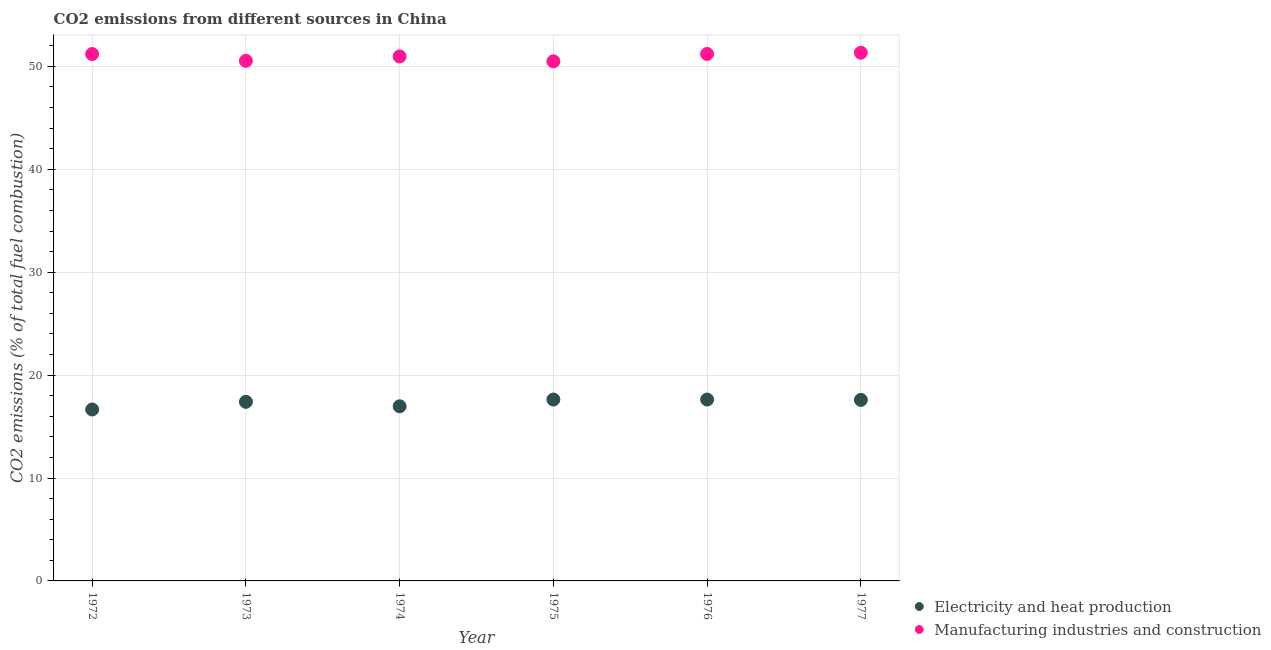Is the number of dotlines equal to the number of legend labels?
Make the answer very short. Yes. What is the co2 emissions due to electricity and heat production in 1973?
Provide a succinct answer. 17.4. Across all years, what is the maximum co2 emissions due to electricity and heat production?
Keep it short and to the point. 17.63. Across all years, what is the minimum co2 emissions due to manufacturing industries?
Offer a terse response. 50.49. In which year was the co2 emissions due to manufacturing industries maximum?
Give a very brief answer. 1977. In which year was the co2 emissions due to electricity and heat production minimum?
Provide a succinct answer. 1972. What is the total co2 emissions due to manufacturing industries in the graph?
Your response must be concise. 305.74. What is the difference between the co2 emissions due to manufacturing industries in 1973 and that in 1977?
Ensure brevity in your answer.  -0.79. What is the difference between the co2 emissions due to electricity and heat production in 1975 and the co2 emissions due to manufacturing industries in 1972?
Provide a short and direct response. -33.57. What is the average co2 emissions due to manufacturing industries per year?
Provide a short and direct response. 50.96. In the year 1976, what is the difference between the co2 emissions due to manufacturing industries and co2 emissions due to electricity and heat production?
Your response must be concise. 33.58. In how many years, is the co2 emissions due to manufacturing industries greater than 4 %?
Keep it short and to the point. 6. What is the ratio of the co2 emissions due to manufacturing industries in 1974 to that in 1976?
Your answer should be very brief. 1. Is the co2 emissions due to electricity and heat production in 1975 less than that in 1976?
Offer a terse response. No. Is the difference between the co2 emissions due to electricity and heat production in 1975 and 1977 greater than the difference between the co2 emissions due to manufacturing industries in 1975 and 1977?
Offer a very short reply. Yes. What is the difference between the highest and the second highest co2 emissions due to electricity and heat production?
Your answer should be very brief. 0. What is the difference between the highest and the lowest co2 emissions due to manufacturing industries?
Provide a succinct answer. 0.84. Does the co2 emissions due to electricity and heat production monotonically increase over the years?
Ensure brevity in your answer.  No. Is the co2 emissions due to electricity and heat production strictly greater than the co2 emissions due to manufacturing industries over the years?
Offer a terse response. No. How many dotlines are there?
Offer a very short reply. 2. How many years are there in the graph?
Keep it short and to the point. 6. What is the difference between two consecutive major ticks on the Y-axis?
Offer a terse response. 10. Are the values on the major ticks of Y-axis written in scientific E-notation?
Ensure brevity in your answer.  No. Does the graph contain any zero values?
Keep it short and to the point. No. Where does the legend appear in the graph?
Your response must be concise. Bottom right. How are the legend labels stacked?
Keep it short and to the point. Vertical. What is the title of the graph?
Give a very brief answer. CO2 emissions from different sources in China. Does "Import" appear as one of the legend labels in the graph?
Give a very brief answer. No. What is the label or title of the Y-axis?
Give a very brief answer. CO2 emissions (% of total fuel combustion). What is the CO2 emissions (% of total fuel combustion) in Electricity and heat production in 1972?
Make the answer very short. 16.66. What is the CO2 emissions (% of total fuel combustion) of Manufacturing industries and construction in 1972?
Keep it short and to the point. 51.2. What is the CO2 emissions (% of total fuel combustion) in Electricity and heat production in 1973?
Offer a terse response. 17.4. What is the CO2 emissions (% of total fuel combustion) of Manufacturing industries and construction in 1973?
Provide a succinct answer. 50.54. What is the CO2 emissions (% of total fuel combustion) of Electricity and heat production in 1974?
Offer a very short reply. 16.97. What is the CO2 emissions (% of total fuel combustion) in Manufacturing industries and construction in 1974?
Provide a succinct answer. 50.97. What is the CO2 emissions (% of total fuel combustion) in Electricity and heat production in 1975?
Your response must be concise. 17.63. What is the CO2 emissions (% of total fuel combustion) of Manufacturing industries and construction in 1975?
Provide a succinct answer. 50.49. What is the CO2 emissions (% of total fuel combustion) of Electricity and heat production in 1976?
Provide a succinct answer. 17.63. What is the CO2 emissions (% of total fuel combustion) of Manufacturing industries and construction in 1976?
Provide a short and direct response. 51.21. What is the CO2 emissions (% of total fuel combustion) in Electricity and heat production in 1977?
Offer a very short reply. 17.59. What is the CO2 emissions (% of total fuel combustion) in Manufacturing industries and construction in 1977?
Your response must be concise. 51.33. Across all years, what is the maximum CO2 emissions (% of total fuel combustion) of Electricity and heat production?
Make the answer very short. 17.63. Across all years, what is the maximum CO2 emissions (% of total fuel combustion) in Manufacturing industries and construction?
Your answer should be very brief. 51.33. Across all years, what is the minimum CO2 emissions (% of total fuel combustion) of Electricity and heat production?
Provide a short and direct response. 16.66. Across all years, what is the minimum CO2 emissions (% of total fuel combustion) in Manufacturing industries and construction?
Your answer should be very brief. 50.49. What is the total CO2 emissions (% of total fuel combustion) in Electricity and heat production in the graph?
Your answer should be compact. 103.87. What is the total CO2 emissions (% of total fuel combustion) of Manufacturing industries and construction in the graph?
Your answer should be compact. 305.74. What is the difference between the CO2 emissions (% of total fuel combustion) in Electricity and heat production in 1972 and that in 1973?
Give a very brief answer. -0.74. What is the difference between the CO2 emissions (% of total fuel combustion) in Manufacturing industries and construction in 1972 and that in 1973?
Offer a terse response. 0.66. What is the difference between the CO2 emissions (% of total fuel combustion) of Electricity and heat production in 1972 and that in 1974?
Ensure brevity in your answer.  -0.31. What is the difference between the CO2 emissions (% of total fuel combustion) in Manufacturing industries and construction in 1972 and that in 1974?
Your response must be concise. 0.24. What is the difference between the CO2 emissions (% of total fuel combustion) in Electricity and heat production in 1972 and that in 1975?
Keep it short and to the point. -0.97. What is the difference between the CO2 emissions (% of total fuel combustion) in Manufacturing industries and construction in 1972 and that in 1975?
Your answer should be very brief. 0.71. What is the difference between the CO2 emissions (% of total fuel combustion) of Electricity and heat production in 1972 and that in 1976?
Make the answer very short. -0.97. What is the difference between the CO2 emissions (% of total fuel combustion) in Manufacturing industries and construction in 1972 and that in 1976?
Offer a very short reply. -0.01. What is the difference between the CO2 emissions (% of total fuel combustion) of Electricity and heat production in 1972 and that in 1977?
Make the answer very short. -0.93. What is the difference between the CO2 emissions (% of total fuel combustion) in Manufacturing industries and construction in 1972 and that in 1977?
Make the answer very short. -0.13. What is the difference between the CO2 emissions (% of total fuel combustion) in Electricity and heat production in 1973 and that in 1974?
Keep it short and to the point. 0.43. What is the difference between the CO2 emissions (% of total fuel combustion) of Manufacturing industries and construction in 1973 and that in 1974?
Provide a succinct answer. -0.42. What is the difference between the CO2 emissions (% of total fuel combustion) in Electricity and heat production in 1973 and that in 1975?
Your response must be concise. -0.22. What is the difference between the CO2 emissions (% of total fuel combustion) in Manufacturing industries and construction in 1973 and that in 1975?
Ensure brevity in your answer.  0.05. What is the difference between the CO2 emissions (% of total fuel combustion) of Electricity and heat production in 1973 and that in 1976?
Give a very brief answer. -0.22. What is the difference between the CO2 emissions (% of total fuel combustion) in Manufacturing industries and construction in 1973 and that in 1976?
Ensure brevity in your answer.  -0.67. What is the difference between the CO2 emissions (% of total fuel combustion) in Electricity and heat production in 1973 and that in 1977?
Offer a very short reply. -0.19. What is the difference between the CO2 emissions (% of total fuel combustion) in Manufacturing industries and construction in 1973 and that in 1977?
Give a very brief answer. -0.79. What is the difference between the CO2 emissions (% of total fuel combustion) in Electricity and heat production in 1974 and that in 1975?
Provide a short and direct response. -0.66. What is the difference between the CO2 emissions (% of total fuel combustion) of Manufacturing industries and construction in 1974 and that in 1975?
Make the answer very short. 0.47. What is the difference between the CO2 emissions (% of total fuel combustion) in Electricity and heat production in 1974 and that in 1976?
Offer a very short reply. -0.66. What is the difference between the CO2 emissions (% of total fuel combustion) of Manufacturing industries and construction in 1974 and that in 1976?
Make the answer very short. -0.24. What is the difference between the CO2 emissions (% of total fuel combustion) of Electricity and heat production in 1974 and that in 1977?
Offer a terse response. -0.62. What is the difference between the CO2 emissions (% of total fuel combustion) in Manufacturing industries and construction in 1974 and that in 1977?
Provide a short and direct response. -0.36. What is the difference between the CO2 emissions (% of total fuel combustion) of Electricity and heat production in 1975 and that in 1976?
Provide a short and direct response. 0. What is the difference between the CO2 emissions (% of total fuel combustion) in Manufacturing industries and construction in 1975 and that in 1976?
Your response must be concise. -0.71. What is the difference between the CO2 emissions (% of total fuel combustion) in Electricity and heat production in 1975 and that in 1977?
Provide a succinct answer. 0.04. What is the difference between the CO2 emissions (% of total fuel combustion) of Manufacturing industries and construction in 1975 and that in 1977?
Give a very brief answer. -0.84. What is the difference between the CO2 emissions (% of total fuel combustion) of Electricity and heat production in 1976 and that in 1977?
Offer a terse response. 0.04. What is the difference between the CO2 emissions (% of total fuel combustion) of Manufacturing industries and construction in 1976 and that in 1977?
Give a very brief answer. -0.12. What is the difference between the CO2 emissions (% of total fuel combustion) of Electricity and heat production in 1972 and the CO2 emissions (% of total fuel combustion) of Manufacturing industries and construction in 1973?
Your response must be concise. -33.88. What is the difference between the CO2 emissions (% of total fuel combustion) in Electricity and heat production in 1972 and the CO2 emissions (% of total fuel combustion) in Manufacturing industries and construction in 1974?
Offer a very short reply. -34.31. What is the difference between the CO2 emissions (% of total fuel combustion) of Electricity and heat production in 1972 and the CO2 emissions (% of total fuel combustion) of Manufacturing industries and construction in 1975?
Make the answer very short. -33.83. What is the difference between the CO2 emissions (% of total fuel combustion) of Electricity and heat production in 1972 and the CO2 emissions (% of total fuel combustion) of Manufacturing industries and construction in 1976?
Your answer should be very brief. -34.55. What is the difference between the CO2 emissions (% of total fuel combustion) in Electricity and heat production in 1972 and the CO2 emissions (% of total fuel combustion) in Manufacturing industries and construction in 1977?
Provide a short and direct response. -34.67. What is the difference between the CO2 emissions (% of total fuel combustion) in Electricity and heat production in 1973 and the CO2 emissions (% of total fuel combustion) in Manufacturing industries and construction in 1974?
Provide a short and direct response. -33.56. What is the difference between the CO2 emissions (% of total fuel combustion) of Electricity and heat production in 1973 and the CO2 emissions (% of total fuel combustion) of Manufacturing industries and construction in 1975?
Offer a very short reply. -33.09. What is the difference between the CO2 emissions (% of total fuel combustion) in Electricity and heat production in 1973 and the CO2 emissions (% of total fuel combustion) in Manufacturing industries and construction in 1976?
Keep it short and to the point. -33.8. What is the difference between the CO2 emissions (% of total fuel combustion) in Electricity and heat production in 1973 and the CO2 emissions (% of total fuel combustion) in Manufacturing industries and construction in 1977?
Provide a short and direct response. -33.93. What is the difference between the CO2 emissions (% of total fuel combustion) of Electricity and heat production in 1974 and the CO2 emissions (% of total fuel combustion) of Manufacturing industries and construction in 1975?
Offer a terse response. -33.52. What is the difference between the CO2 emissions (% of total fuel combustion) in Electricity and heat production in 1974 and the CO2 emissions (% of total fuel combustion) in Manufacturing industries and construction in 1976?
Offer a very short reply. -34.24. What is the difference between the CO2 emissions (% of total fuel combustion) in Electricity and heat production in 1974 and the CO2 emissions (% of total fuel combustion) in Manufacturing industries and construction in 1977?
Your answer should be very brief. -34.36. What is the difference between the CO2 emissions (% of total fuel combustion) in Electricity and heat production in 1975 and the CO2 emissions (% of total fuel combustion) in Manufacturing industries and construction in 1976?
Your response must be concise. -33.58. What is the difference between the CO2 emissions (% of total fuel combustion) of Electricity and heat production in 1975 and the CO2 emissions (% of total fuel combustion) of Manufacturing industries and construction in 1977?
Provide a short and direct response. -33.7. What is the difference between the CO2 emissions (% of total fuel combustion) in Electricity and heat production in 1976 and the CO2 emissions (% of total fuel combustion) in Manufacturing industries and construction in 1977?
Your response must be concise. -33.7. What is the average CO2 emissions (% of total fuel combustion) in Electricity and heat production per year?
Your answer should be very brief. 17.31. What is the average CO2 emissions (% of total fuel combustion) of Manufacturing industries and construction per year?
Give a very brief answer. 50.96. In the year 1972, what is the difference between the CO2 emissions (% of total fuel combustion) in Electricity and heat production and CO2 emissions (% of total fuel combustion) in Manufacturing industries and construction?
Ensure brevity in your answer.  -34.54. In the year 1973, what is the difference between the CO2 emissions (% of total fuel combustion) in Electricity and heat production and CO2 emissions (% of total fuel combustion) in Manufacturing industries and construction?
Make the answer very short. -33.14. In the year 1974, what is the difference between the CO2 emissions (% of total fuel combustion) of Electricity and heat production and CO2 emissions (% of total fuel combustion) of Manufacturing industries and construction?
Your answer should be compact. -34. In the year 1975, what is the difference between the CO2 emissions (% of total fuel combustion) in Electricity and heat production and CO2 emissions (% of total fuel combustion) in Manufacturing industries and construction?
Make the answer very short. -32.87. In the year 1976, what is the difference between the CO2 emissions (% of total fuel combustion) in Electricity and heat production and CO2 emissions (% of total fuel combustion) in Manufacturing industries and construction?
Make the answer very short. -33.58. In the year 1977, what is the difference between the CO2 emissions (% of total fuel combustion) of Electricity and heat production and CO2 emissions (% of total fuel combustion) of Manufacturing industries and construction?
Offer a terse response. -33.74. What is the ratio of the CO2 emissions (% of total fuel combustion) of Electricity and heat production in 1972 to that in 1973?
Make the answer very short. 0.96. What is the ratio of the CO2 emissions (% of total fuel combustion) in Manufacturing industries and construction in 1972 to that in 1973?
Offer a terse response. 1.01. What is the ratio of the CO2 emissions (% of total fuel combustion) in Electricity and heat production in 1972 to that in 1974?
Ensure brevity in your answer.  0.98. What is the ratio of the CO2 emissions (% of total fuel combustion) in Electricity and heat production in 1972 to that in 1975?
Your response must be concise. 0.95. What is the ratio of the CO2 emissions (% of total fuel combustion) of Manufacturing industries and construction in 1972 to that in 1975?
Keep it short and to the point. 1.01. What is the ratio of the CO2 emissions (% of total fuel combustion) of Electricity and heat production in 1972 to that in 1976?
Make the answer very short. 0.95. What is the ratio of the CO2 emissions (% of total fuel combustion) of Manufacturing industries and construction in 1972 to that in 1976?
Keep it short and to the point. 1. What is the ratio of the CO2 emissions (% of total fuel combustion) of Electricity and heat production in 1972 to that in 1977?
Offer a terse response. 0.95. What is the ratio of the CO2 emissions (% of total fuel combustion) in Manufacturing industries and construction in 1972 to that in 1977?
Provide a short and direct response. 1. What is the ratio of the CO2 emissions (% of total fuel combustion) in Electricity and heat production in 1973 to that in 1974?
Offer a very short reply. 1.03. What is the ratio of the CO2 emissions (% of total fuel combustion) of Electricity and heat production in 1973 to that in 1975?
Your response must be concise. 0.99. What is the ratio of the CO2 emissions (% of total fuel combustion) in Manufacturing industries and construction in 1973 to that in 1975?
Offer a terse response. 1. What is the ratio of the CO2 emissions (% of total fuel combustion) in Electricity and heat production in 1973 to that in 1976?
Offer a very short reply. 0.99. What is the ratio of the CO2 emissions (% of total fuel combustion) of Electricity and heat production in 1973 to that in 1977?
Make the answer very short. 0.99. What is the ratio of the CO2 emissions (% of total fuel combustion) of Manufacturing industries and construction in 1973 to that in 1977?
Provide a succinct answer. 0.98. What is the ratio of the CO2 emissions (% of total fuel combustion) of Electricity and heat production in 1974 to that in 1975?
Your response must be concise. 0.96. What is the ratio of the CO2 emissions (% of total fuel combustion) in Manufacturing industries and construction in 1974 to that in 1975?
Make the answer very short. 1.01. What is the ratio of the CO2 emissions (% of total fuel combustion) in Electricity and heat production in 1974 to that in 1976?
Keep it short and to the point. 0.96. What is the ratio of the CO2 emissions (% of total fuel combustion) of Electricity and heat production in 1974 to that in 1977?
Give a very brief answer. 0.96. What is the ratio of the CO2 emissions (% of total fuel combustion) of Manufacturing industries and construction in 1974 to that in 1977?
Make the answer very short. 0.99. What is the ratio of the CO2 emissions (% of total fuel combustion) of Electricity and heat production in 1975 to that in 1977?
Provide a succinct answer. 1. What is the ratio of the CO2 emissions (% of total fuel combustion) in Manufacturing industries and construction in 1975 to that in 1977?
Provide a short and direct response. 0.98. What is the ratio of the CO2 emissions (% of total fuel combustion) in Electricity and heat production in 1976 to that in 1977?
Your answer should be very brief. 1. What is the difference between the highest and the second highest CO2 emissions (% of total fuel combustion) of Electricity and heat production?
Provide a succinct answer. 0. What is the difference between the highest and the second highest CO2 emissions (% of total fuel combustion) in Manufacturing industries and construction?
Your answer should be compact. 0.12. What is the difference between the highest and the lowest CO2 emissions (% of total fuel combustion) in Electricity and heat production?
Provide a short and direct response. 0.97. What is the difference between the highest and the lowest CO2 emissions (% of total fuel combustion) in Manufacturing industries and construction?
Give a very brief answer. 0.84. 